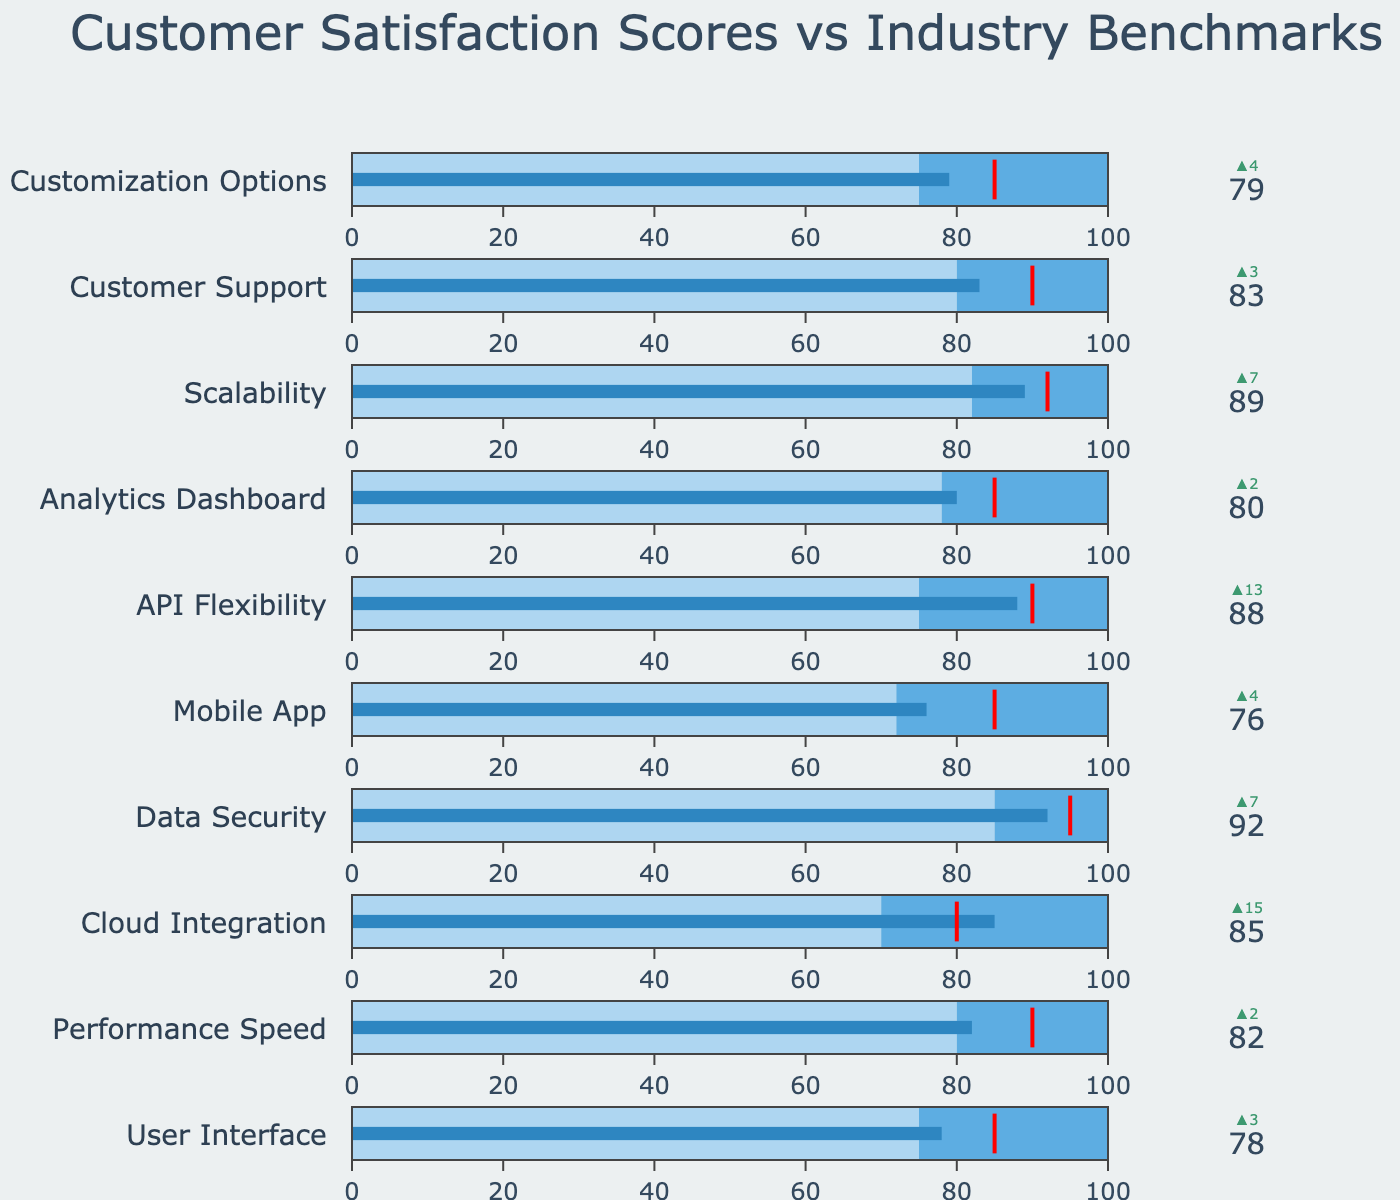What's the title of the figure? The title can be found at the top of the chart. It is generally a larger text that summarizes what the chart is about.
Answer: Customer Satisfaction Scores vs Industry Benchmarks Which feature has the highest customer satisfaction score? You can determine the highest satisfaction score by looking at each feature's gauge and comparing their values. Data Security has the highest score at 92.
Answer: Data Security What is the customer satisfaction score for the User Interface, and how does it compare to the industry benchmark? The score for User Interface can be found on its gauge, and the industry benchmark can be seen in the delta and steps in different colors. The score is 78, which is 3 points higher than the industry benchmark of 75.
Answer: 78, 3 points higher Which feature has the largest delta between the customer satisfaction score and the industry benchmark? By examining the delta indicators, determine which feature has the largest difference (positive or negative) between the customer satisfaction score and the industry benchmark. Cloud Integration has a delta of 15 points over the benchmark.
Answer: Cloud Integration How many features meet or exceed their target satisfaction score? Identify the features whose satisfaction score bar reaches or surpasses the red threshold line, indicating the target score. Based on the chart, no features fully meet or exceed their target satisfaction score.
Answer: 0 Which feature's customer satisfaction score is closest to its target? Determine the smallest difference between the satisfaction score and the target score by examining the positions of the bars relative to the red threshold lines. Data Security has a score of 92, which is only 3 points below its target of 95.
Answer: Data Security What is the difference between the scores of Mobile App and Customer Support? Check the satisfaction scores of Mobile App (76) and Customer Support (83) and subtract the first from the second. The difference is 83 - 76 = 7.
Answer: 7 Which feature has the second-highest customer satisfaction score? After identifying the feature with the highest score (Data Security), find the next highest score. Scalability has the second-highest score at 89.
Answer: Scalability Which feature has both a customer satisfaction score and an industry benchmark above 80? Scan through the list and identify features where both values exceed 80. Data Security, Performance Speed, and Customer Support all fit this criteria.
Answer: Data Security, Performance Speed, Customer Support How much higher is API Flexibility’s satisfaction score compared to its industry benchmark? Note the satisfaction score of API Flexibility (88) and its industry benchmark (75), and subtract the benchmark from the score: 88 - 75 = 13.
Answer: 13 